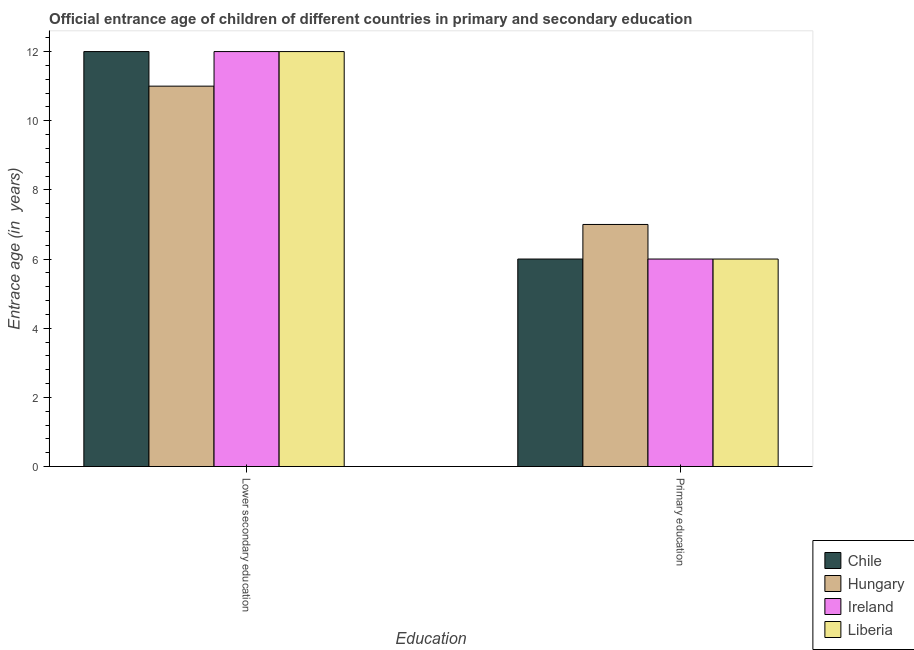How many different coloured bars are there?
Provide a succinct answer. 4. How many groups of bars are there?
Your answer should be compact. 2. Are the number of bars per tick equal to the number of legend labels?
Your answer should be very brief. Yes. Are the number of bars on each tick of the X-axis equal?
Your answer should be very brief. Yes. How many bars are there on the 2nd tick from the right?
Offer a very short reply. 4. What is the label of the 1st group of bars from the left?
Make the answer very short. Lower secondary education. Across all countries, what is the maximum entrance age of children in lower secondary education?
Your answer should be very brief. 12. In which country was the entrance age of children in lower secondary education maximum?
Offer a terse response. Chile. In which country was the entrance age of children in lower secondary education minimum?
Provide a succinct answer. Hungary. What is the total entrance age of children in lower secondary education in the graph?
Make the answer very short. 47. What is the difference between the entrance age of children in lower secondary education in Liberia and that in Chile?
Your response must be concise. 0. What is the difference between the entrance age of children in lower secondary education in Liberia and the entrance age of chiildren in primary education in Hungary?
Provide a short and direct response. 5. What is the average entrance age of children in lower secondary education per country?
Your answer should be very brief. 11.75. What is the difference between the entrance age of children in lower secondary education and entrance age of chiildren in primary education in Ireland?
Your answer should be compact. 6. What is the ratio of the entrance age of chiildren in primary education in Chile to that in Hungary?
Give a very brief answer. 0.86. Is the entrance age of children in lower secondary education in Liberia less than that in Hungary?
Provide a short and direct response. No. What does the 2nd bar from the left in Primary education represents?
Provide a succinct answer. Hungary. How many bars are there?
Offer a very short reply. 8. Are all the bars in the graph horizontal?
Offer a very short reply. No. How many countries are there in the graph?
Provide a succinct answer. 4. Are the values on the major ticks of Y-axis written in scientific E-notation?
Ensure brevity in your answer.  No. Does the graph contain any zero values?
Make the answer very short. No. Does the graph contain grids?
Keep it short and to the point. No. How are the legend labels stacked?
Ensure brevity in your answer.  Vertical. What is the title of the graph?
Your response must be concise. Official entrance age of children of different countries in primary and secondary education. Does "United States" appear as one of the legend labels in the graph?
Offer a terse response. No. What is the label or title of the X-axis?
Your answer should be compact. Education. What is the label or title of the Y-axis?
Provide a short and direct response. Entrace age (in  years). What is the Entrace age (in  years) in Chile in Lower secondary education?
Provide a short and direct response. 12. What is the Entrace age (in  years) of Ireland in Lower secondary education?
Offer a very short reply. 12. What is the Entrace age (in  years) in Chile in Primary education?
Give a very brief answer. 6. What is the Entrace age (in  years) in Ireland in Primary education?
Keep it short and to the point. 6. What is the Entrace age (in  years) in Liberia in Primary education?
Give a very brief answer. 6. Across all Education, what is the maximum Entrace age (in  years) of Hungary?
Your answer should be very brief. 11. Across all Education, what is the minimum Entrace age (in  years) in Chile?
Give a very brief answer. 6. Across all Education, what is the minimum Entrace age (in  years) in Hungary?
Offer a very short reply. 7. Across all Education, what is the minimum Entrace age (in  years) in Ireland?
Keep it short and to the point. 6. Across all Education, what is the minimum Entrace age (in  years) of Liberia?
Make the answer very short. 6. What is the total Entrace age (in  years) of Chile in the graph?
Provide a succinct answer. 18. What is the total Entrace age (in  years) of Ireland in the graph?
Your answer should be compact. 18. What is the difference between the Entrace age (in  years) of Liberia in Lower secondary education and that in Primary education?
Your answer should be very brief. 6. What is the difference between the Entrace age (in  years) in Hungary in Lower secondary education and the Entrace age (in  years) in Ireland in Primary education?
Your answer should be very brief. 5. What is the average Entrace age (in  years) in Hungary per Education?
Offer a very short reply. 9. What is the average Entrace age (in  years) in Liberia per Education?
Offer a very short reply. 9. What is the difference between the Entrace age (in  years) in Hungary and Entrace age (in  years) in Liberia in Lower secondary education?
Make the answer very short. -1. What is the difference between the Entrace age (in  years) of Ireland and Entrace age (in  years) of Liberia in Lower secondary education?
Make the answer very short. 0. What is the difference between the Entrace age (in  years) in Hungary and Entrace age (in  years) in Ireland in Primary education?
Make the answer very short. 1. What is the difference between the Entrace age (in  years) of Hungary and Entrace age (in  years) of Liberia in Primary education?
Provide a short and direct response. 1. What is the difference between the Entrace age (in  years) of Ireland and Entrace age (in  years) of Liberia in Primary education?
Your answer should be very brief. 0. What is the ratio of the Entrace age (in  years) of Hungary in Lower secondary education to that in Primary education?
Your response must be concise. 1.57. What is the ratio of the Entrace age (in  years) of Ireland in Lower secondary education to that in Primary education?
Your response must be concise. 2. What is the difference between the highest and the lowest Entrace age (in  years) of Chile?
Provide a short and direct response. 6. What is the difference between the highest and the lowest Entrace age (in  years) in Hungary?
Provide a succinct answer. 4. What is the difference between the highest and the lowest Entrace age (in  years) in Ireland?
Offer a very short reply. 6. What is the difference between the highest and the lowest Entrace age (in  years) in Liberia?
Your answer should be compact. 6. 